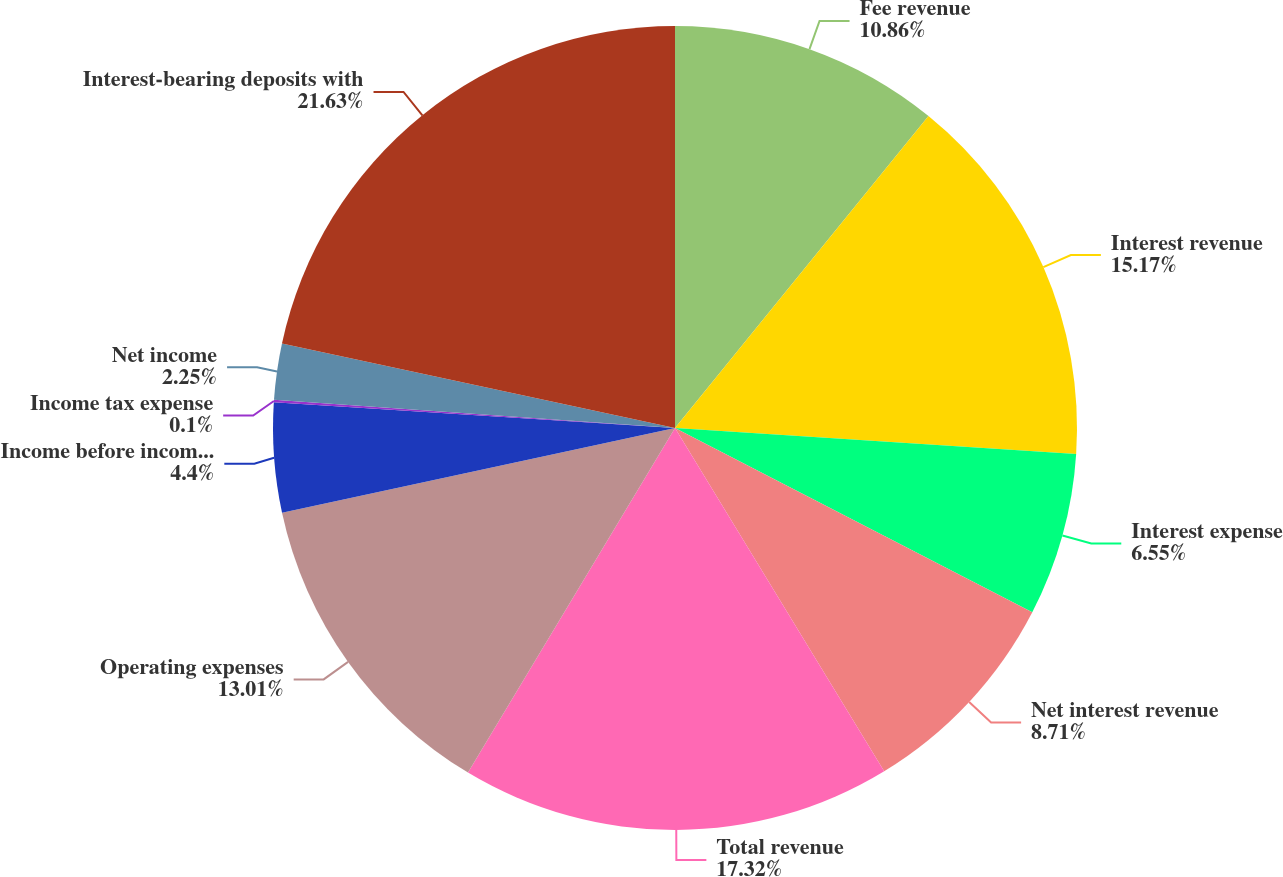<chart> <loc_0><loc_0><loc_500><loc_500><pie_chart><fcel>Fee revenue<fcel>Interest revenue<fcel>Interest expense<fcel>Net interest revenue<fcel>Total revenue<fcel>Operating expenses<fcel>Income before income taxes<fcel>Income tax expense<fcel>Net income<fcel>Interest-bearing deposits with<nl><fcel>10.86%<fcel>15.17%<fcel>6.55%<fcel>8.71%<fcel>17.32%<fcel>13.01%<fcel>4.4%<fcel>0.1%<fcel>2.25%<fcel>21.63%<nl></chart> 